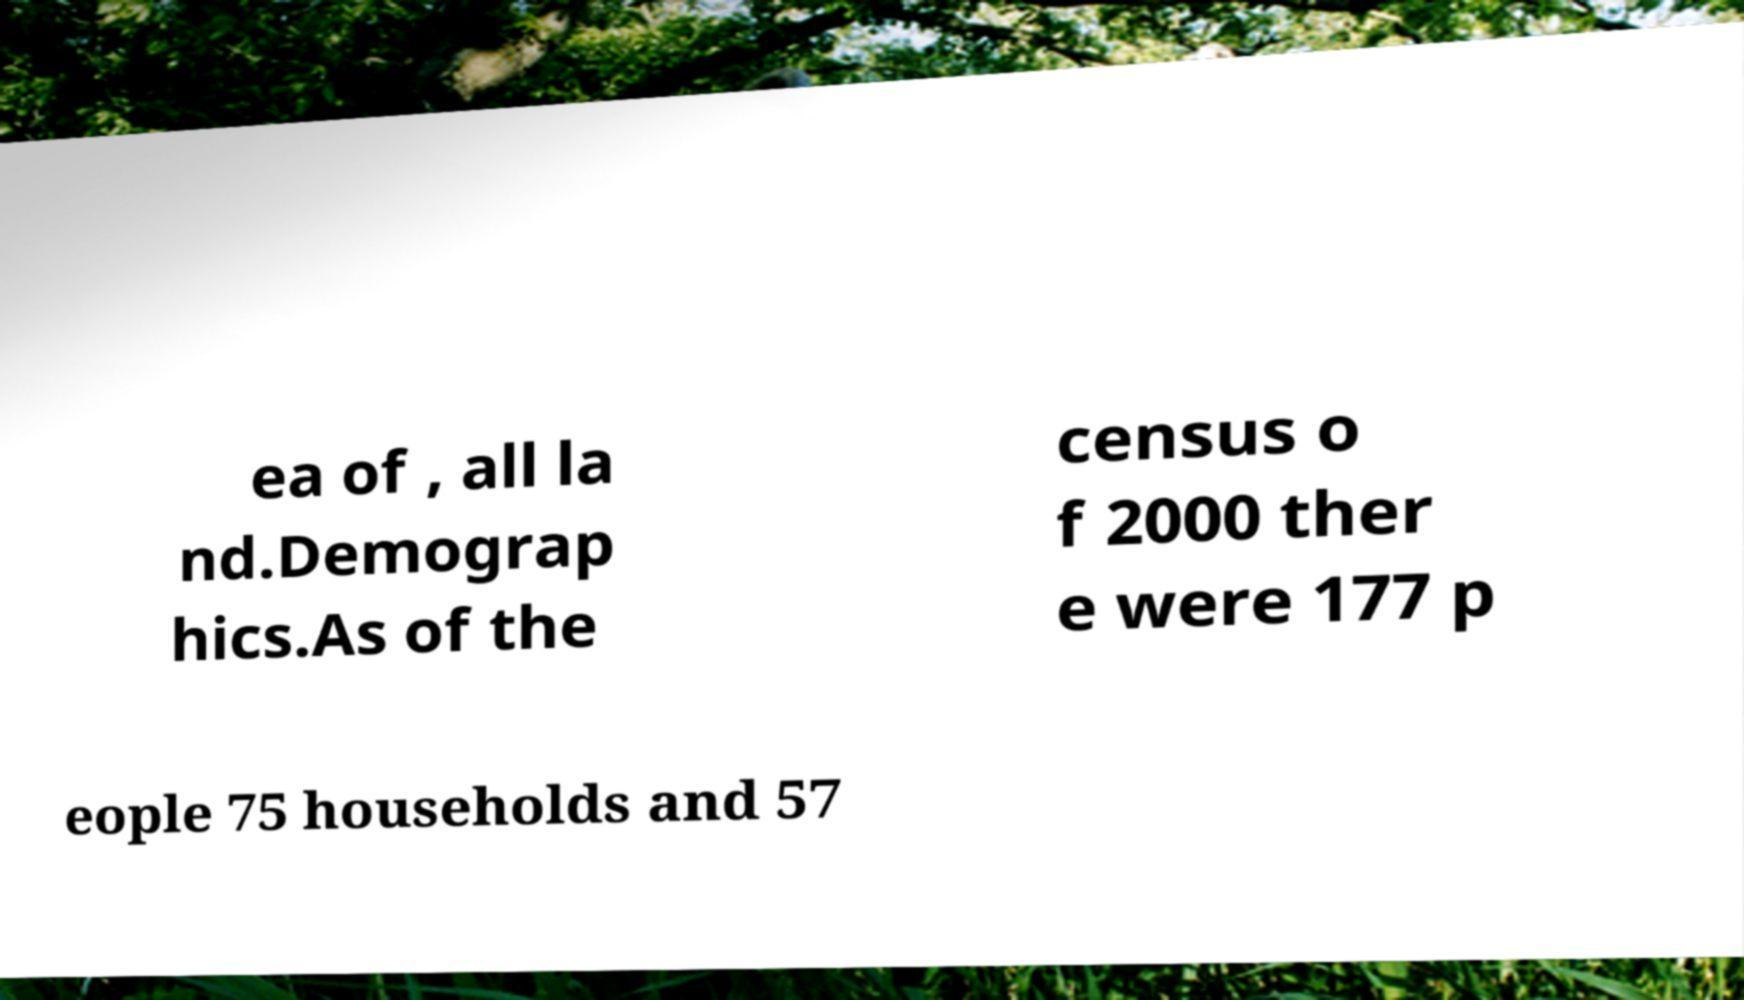I need the written content from this picture converted into text. Can you do that? ea of , all la nd.Demograp hics.As of the census o f 2000 ther e were 177 p eople 75 households and 57 